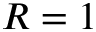<formula> <loc_0><loc_0><loc_500><loc_500>R = 1</formula> 